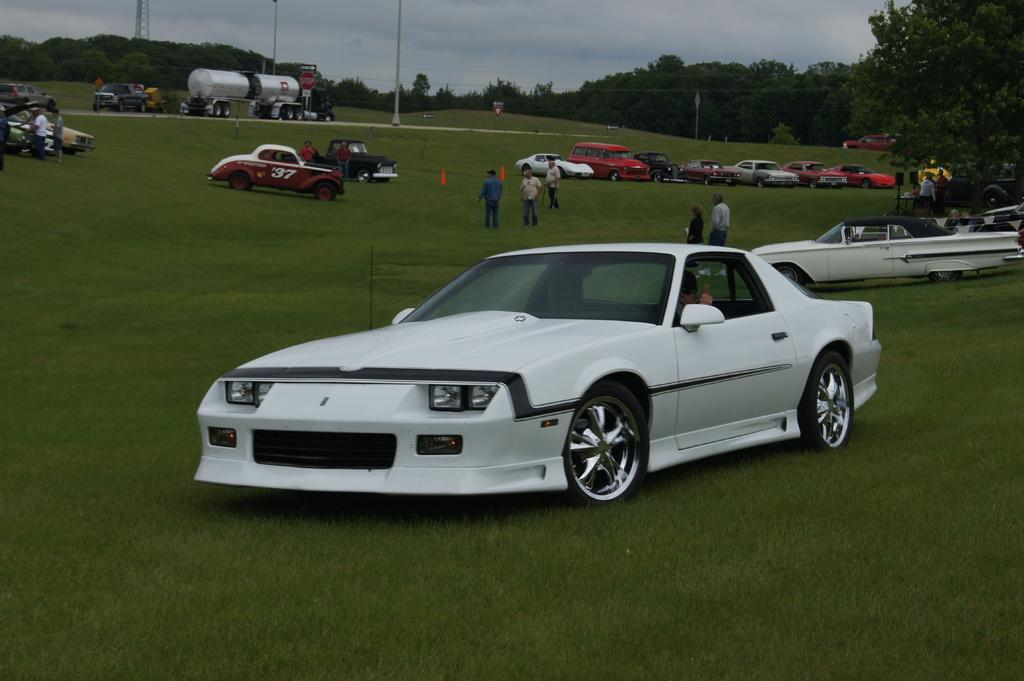What can be seen in the image involving people? There are people standing in the image. What else is present on the ground in the image? There are vehicles on the ground in the image. What type of natural elements are visible in the image? There are trees in the image. What structures can be seen in the image? There are poles and a tower in the image. What object is present for displaying information or advertisements? There is a board in the image. What is visible in the background of the image? The sky is visible in the image. What type of waste can be seen on the ground in the image? There is no waste present on the ground in the image. How does the sleet affect the people standing in the image? There is no mention of sleet in the image, so its effect on the people cannot be determined. 